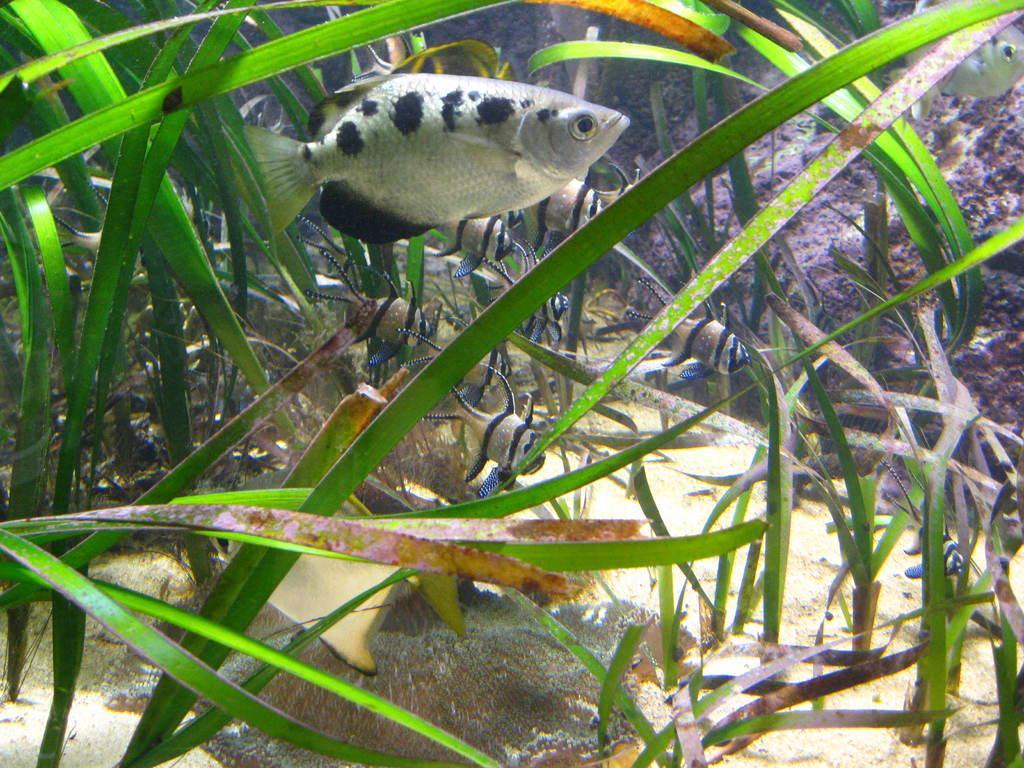Could you give a brief overview of what you see in this image? In this picture we can see fish and plants. 